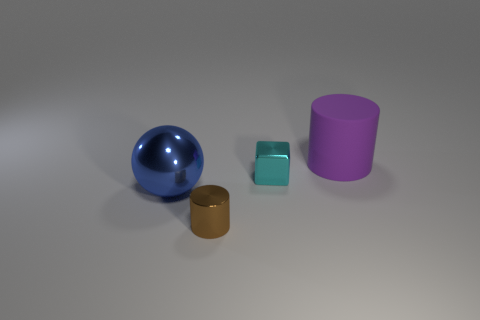Add 4 small brown metallic things. How many objects exist? 8 Subtract all purple cylinders. How many cylinders are left? 1 Subtract all balls. How many objects are left? 3 Subtract all green cylinders. Subtract all purple blocks. How many cylinders are left? 2 Subtract all red blocks. How many purple cylinders are left? 1 Subtract all blue metallic cylinders. Subtract all blue balls. How many objects are left? 3 Add 2 big objects. How many big objects are left? 4 Add 3 red rubber objects. How many red rubber objects exist? 3 Subtract 0 green spheres. How many objects are left? 4 Subtract 1 cubes. How many cubes are left? 0 